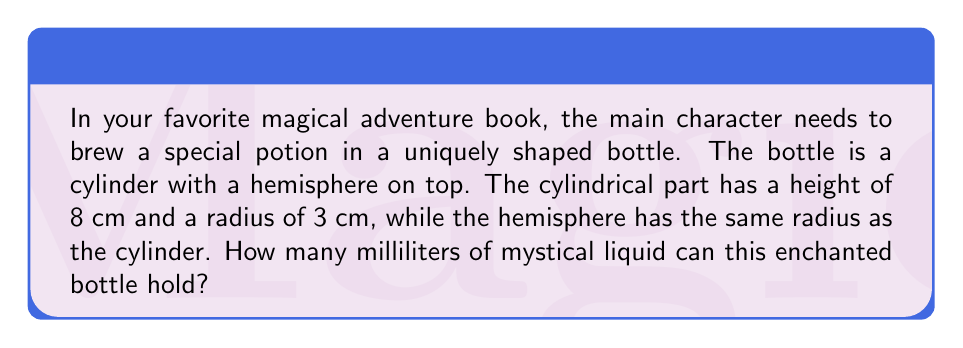Give your solution to this math problem. Let's break this down step-by-step:

1) First, we need to calculate the volume of the cylindrical part:
   $$V_{cylinder} = \pi r^2 h$$
   where $r$ is the radius and $h$ is the height.
   $$V_{cylinder} = \pi \cdot 3^2 \cdot 8 = 72\pi \text{ cm}^3$$

2) Next, we calculate the volume of the hemisphere:
   $$V_{hemisphere} = \frac{2}{3}\pi r^3$$
   $$V_{hemisphere} = \frac{2}{3}\pi \cdot 3^3 = 18\pi \text{ cm}^3$$

3) The total volume is the sum of these two parts:
   $$V_{total} = V_{cylinder} + V_{hemisphere}$$
   $$V_{total} = 72\pi + 18\pi = 90\pi \text{ cm}^3$$

4) Now, we need to convert cubic centimeters to milliliters:
   1 cm³ = 1 mL, so no conversion is necessary.

5) Let's calculate the final value:
   $$90\pi \approx 282.7433 \text{ mL}$$

Therefore, the enchanted bottle can hold approximately 282.7 mL of mystical liquid.
Answer: 282.7 mL 